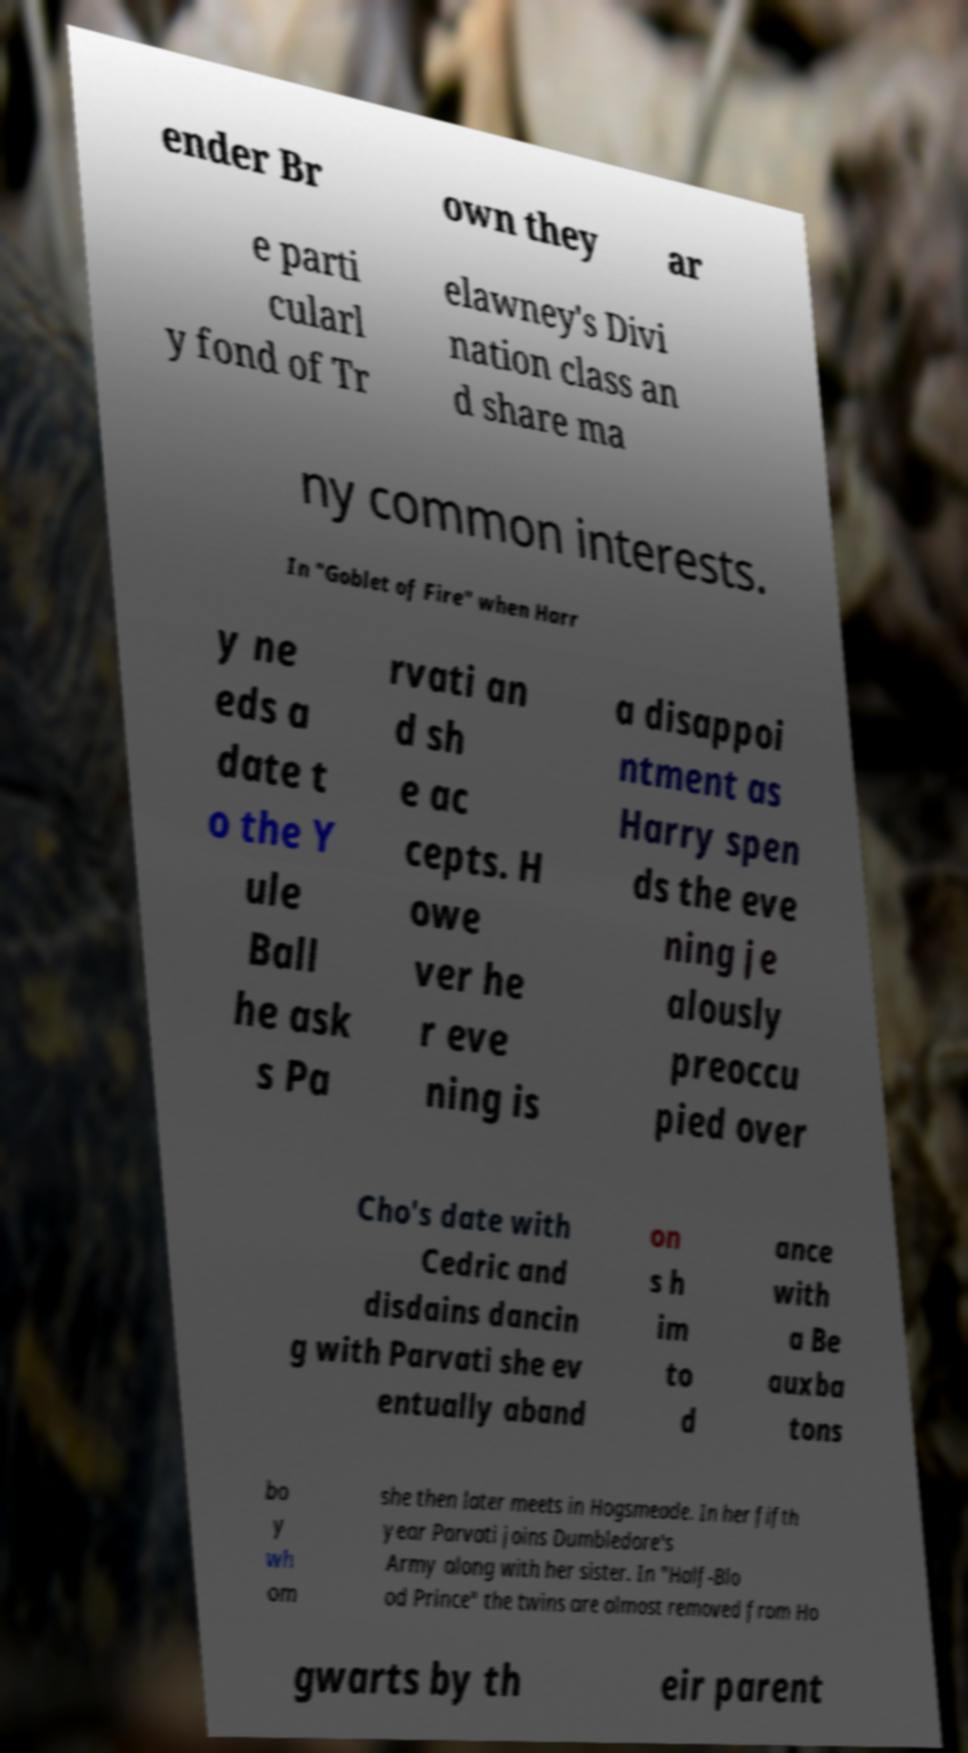What messages or text are displayed in this image? I need them in a readable, typed format. ender Br own they ar e parti cularl y fond of Tr elawney's Divi nation class an d share ma ny common interests. In "Goblet of Fire" when Harr y ne eds a date t o the Y ule Ball he ask s Pa rvati an d sh e ac cepts. H owe ver he r eve ning is a disappoi ntment as Harry spen ds the eve ning je alously preoccu pied over Cho's date with Cedric and disdains dancin g with Parvati she ev entually aband on s h im to d ance with a Be auxba tons bo y wh om she then later meets in Hogsmeade. In her fifth year Parvati joins Dumbledore's Army along with her sister. In "Half-Blo od Prince" the twins are almost removed from Ho gwarts by th eir parent 